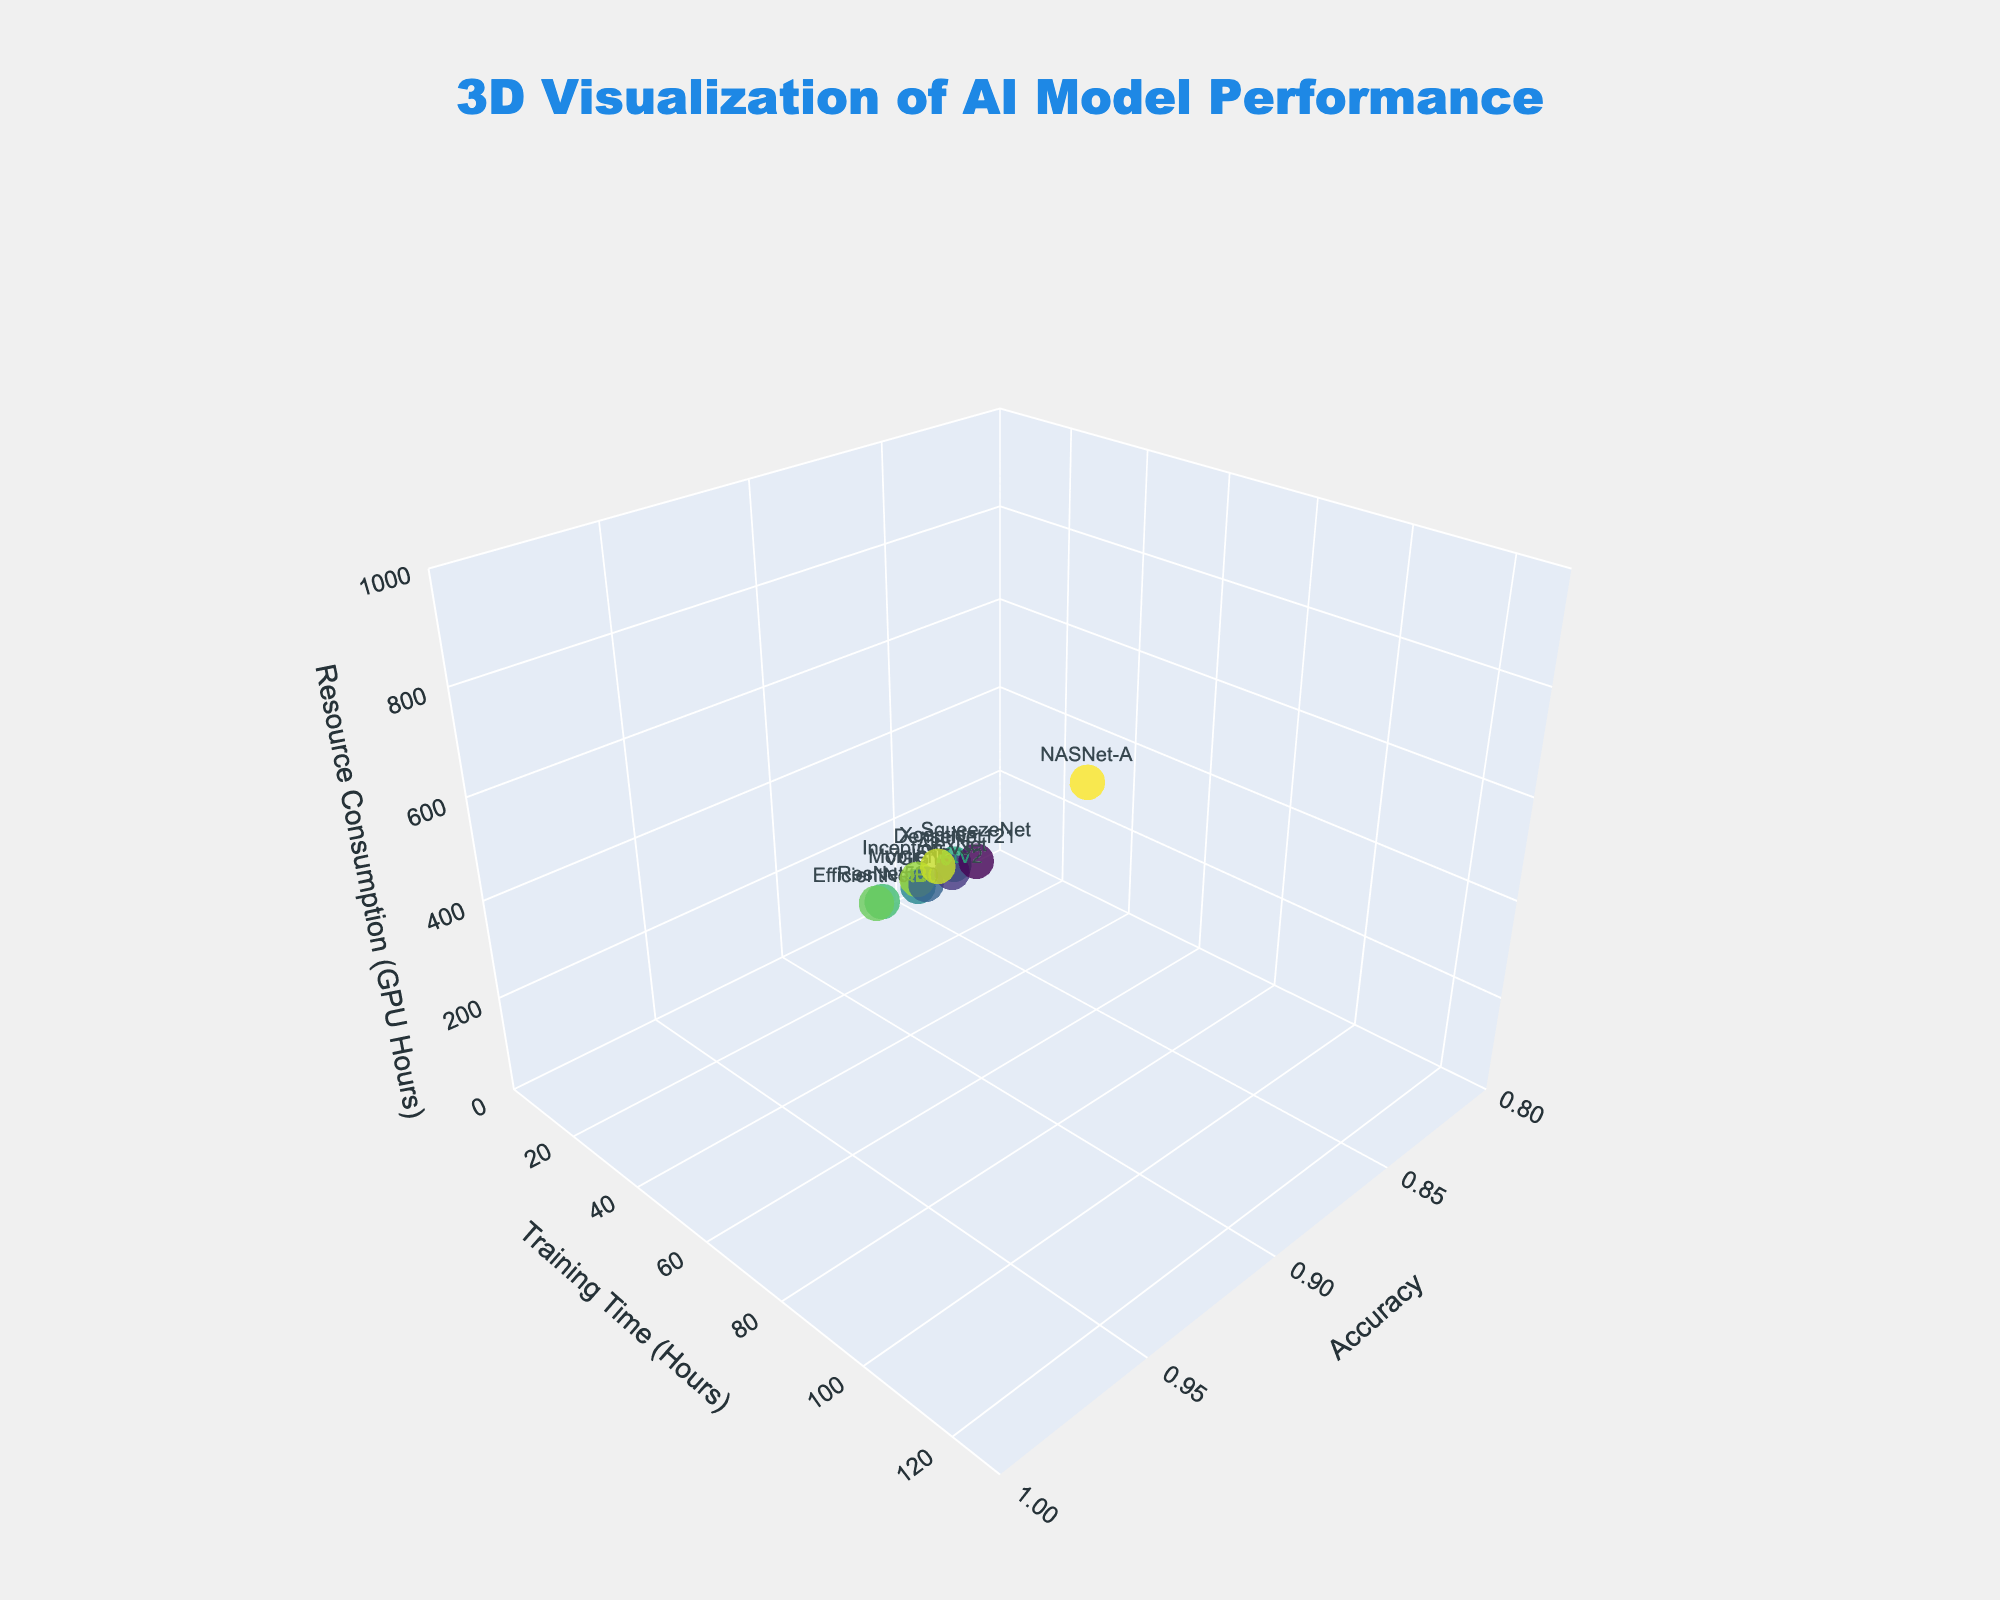what is the title of the plot? The plot's title is centrally placed at the top and uses a large font size. It reads "3D Visualization of AI Model Performance".
Answer: 3D Visualization of AI Model Performance How many neural network architectures are visualized in the plot? By counting the number of data points or labels in the figure, we see that there are 10 distinct neural network architectures displayed.
Answer: 10 Which architecture has the highest accuracy? From the plot, the architecture with the highest accuracy, represented by the farthest data point along the x-axis, is NASNet-A with an accuracy of 0.96.
Answer: NASNet-A What is the range for the training time axis? By looking at the y-axis labels, the range for the training time axis is from 0 to 130 hours.
Answer: 0 to 130 hours Which architecture consumes the most GPU hours? By observing the highest data point along the z-axis, NASNet-A consumes the most GPU hours with a value of 960.
Answer: NASNet-A What is the general relationship between training time and resource consumption? From the plot, there is a positive correlation between training time and resource consumption; architectures with higher training times also consume more GPU hours.
Answer: positive correlation Compare ResNet50 and VGG16 in terms of accuracy and training time. ResNet50 has a slightly higher accuracy of 0.92 versus VGG16's 0.89 and also has a longer training time of 48 hours compared to VGG16's 36 hours.
Answer: ResNet50 has higher accuracy and longer training time Which architecture has the lowest accuracy and what is its training time? By identifying the data point with the lowest x-axis value, SqueezeNet has the lowest accuracy at 0.83, and its training time is 12 hours.
Answer: SqueezeNet, 12 hours What is the average accuracy of all the architectures? Summing up all the accuracy values: (0.92 + 0.89 + 0.94 + 0.87 + 0.91 + 0.93 + 0.85 + 0.83 + 0.95 + 0.96) = 9.05, then dividing by 10 (the number of architectures), the average accuracy is 9.05/10 = 0.905.
Answer: 0.905 Which architecture is the most efficient in terms of resource consumption per accuracy achieved? To determine efficiency, divide Resource Consumption by Accuracy for each architecture. The architecture with the lowest ratio is the most efficient. MobileNetV2 consumes 192 GPU hours with an accuracy of 0.87, resulting in a ratio of 192/0.87 ≈ 220.69, which is the lowest compared to others.
Answer: MobileNetV2 